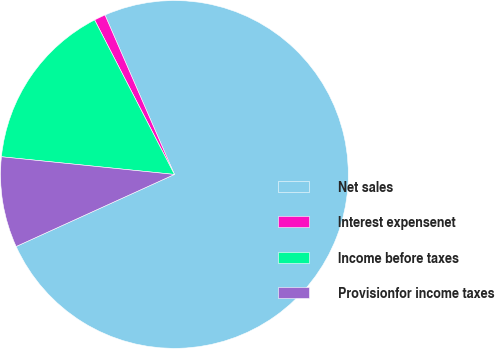Convert chart. <chart><loc_0><loc_0><loc_500><loc_500><pie_chart><fcel>Net sales<fcel>Interest expensenet<fcel>Income before taxes<fcel>Provisionfor income taxes<nl><fcel>74.74%<fcel>1.05%<fcel>15.79%<fcel>8.42%<nl></chart> 